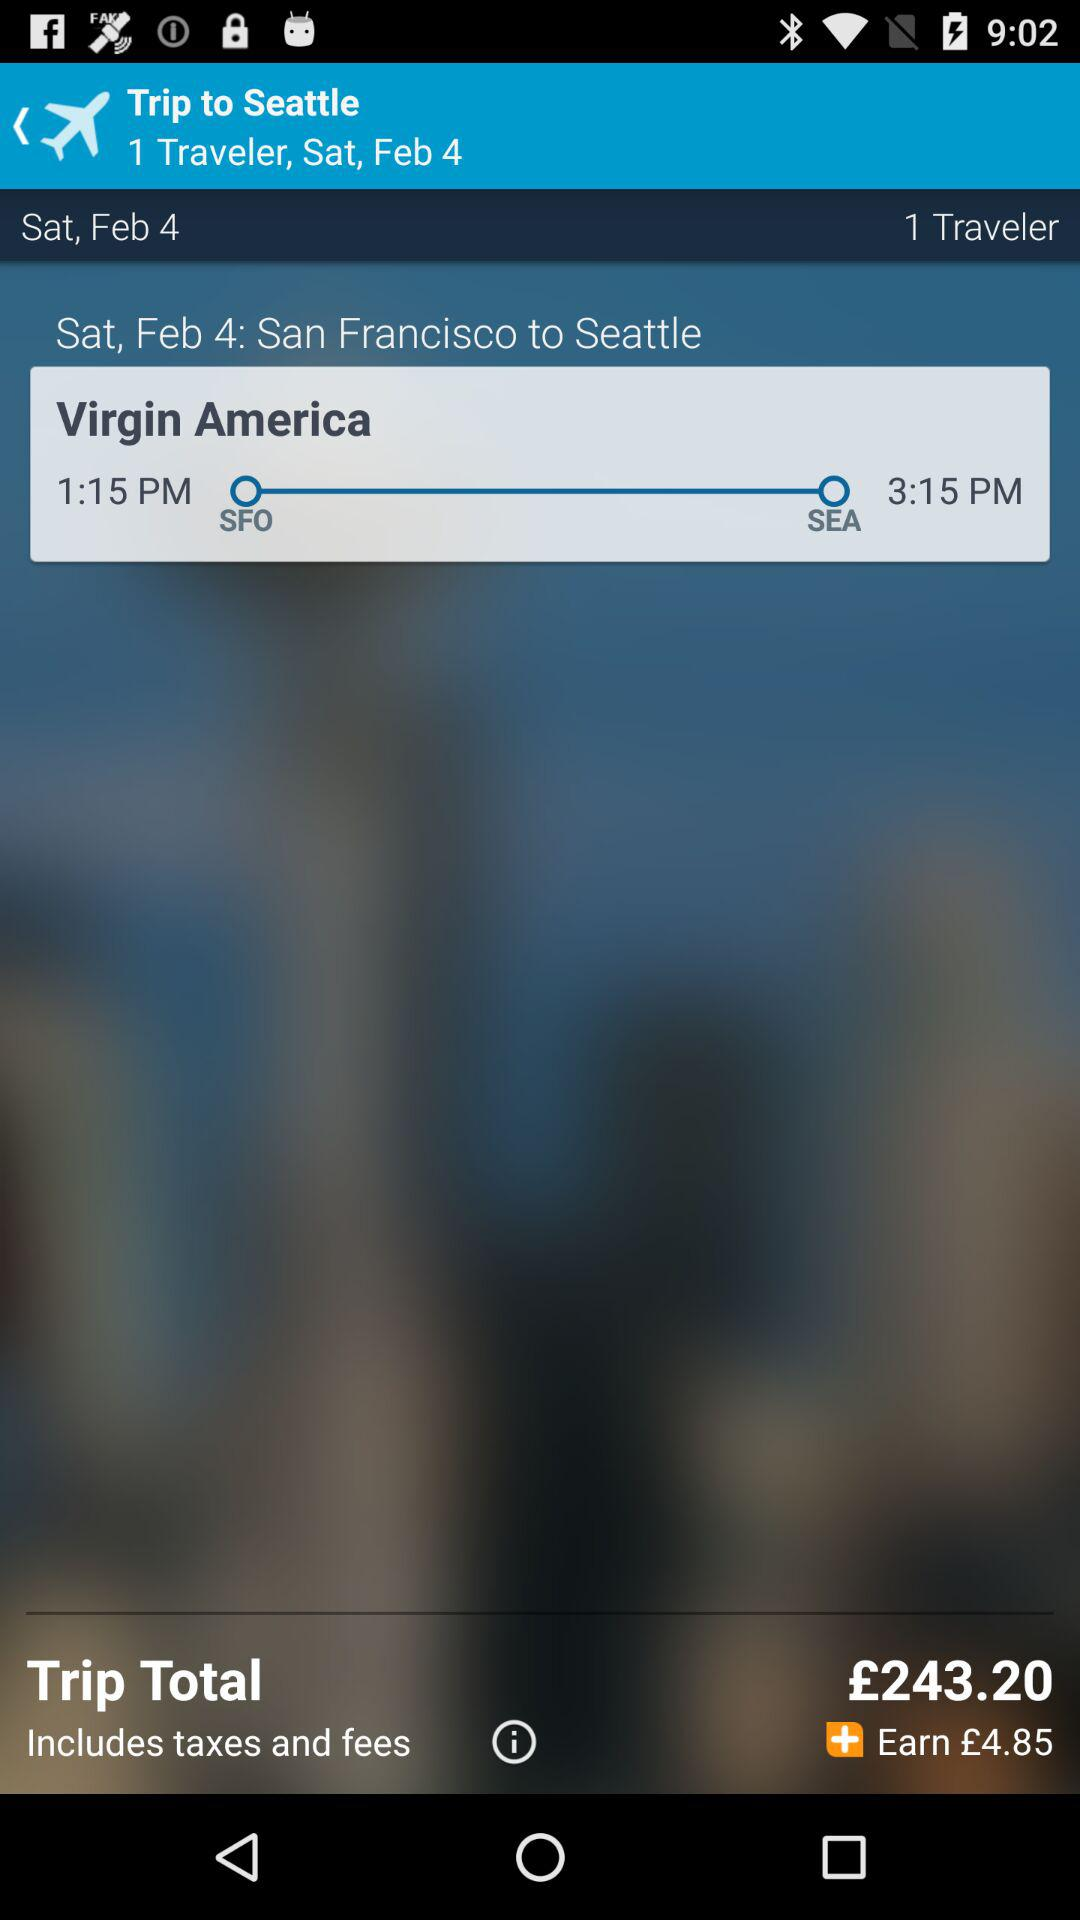What is the mentioned date? The mentioned date is Saturday, February 4. 